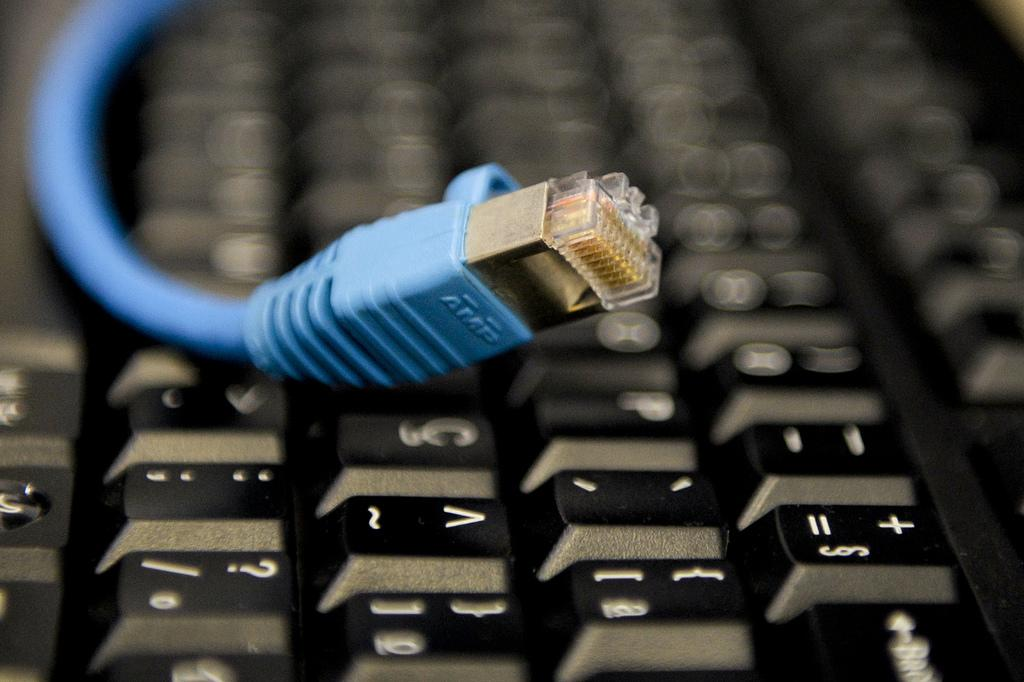Provide a one-sentence caption for the provided image. the blue AMP cable is on top of the keyboard. 